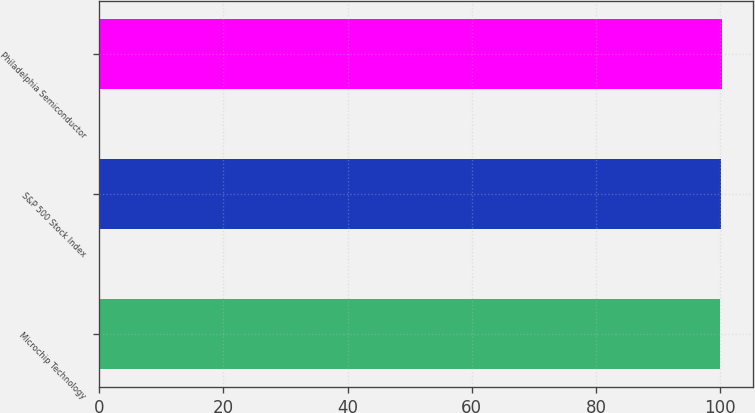Convert chart to OTSL. <chart><loc_0><loc_0><loc_500><loc_500><bar_chart><fcel>Microchip Technology<fcel>S&P 500 Stock Index<fcel>Philadelphia Semiconductor<nl><fcel>100<fcel>100.1<fcel>100.2<nl></chart> 